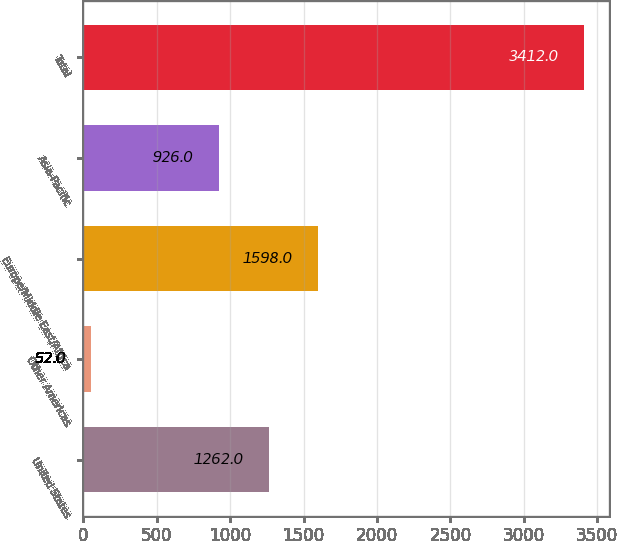<chart> <loc_0><loc_0><loc_500><loc_500><bar_chart><fcel>United States<fcel>Other Americas<fcel>Europe/Middle East/Africa<fcel>Asia-Pacific<fcel>Total<nl><fcel>1262<fcel>52<fcel>1598<fcel>926<fcel>3412<nl></chart> 